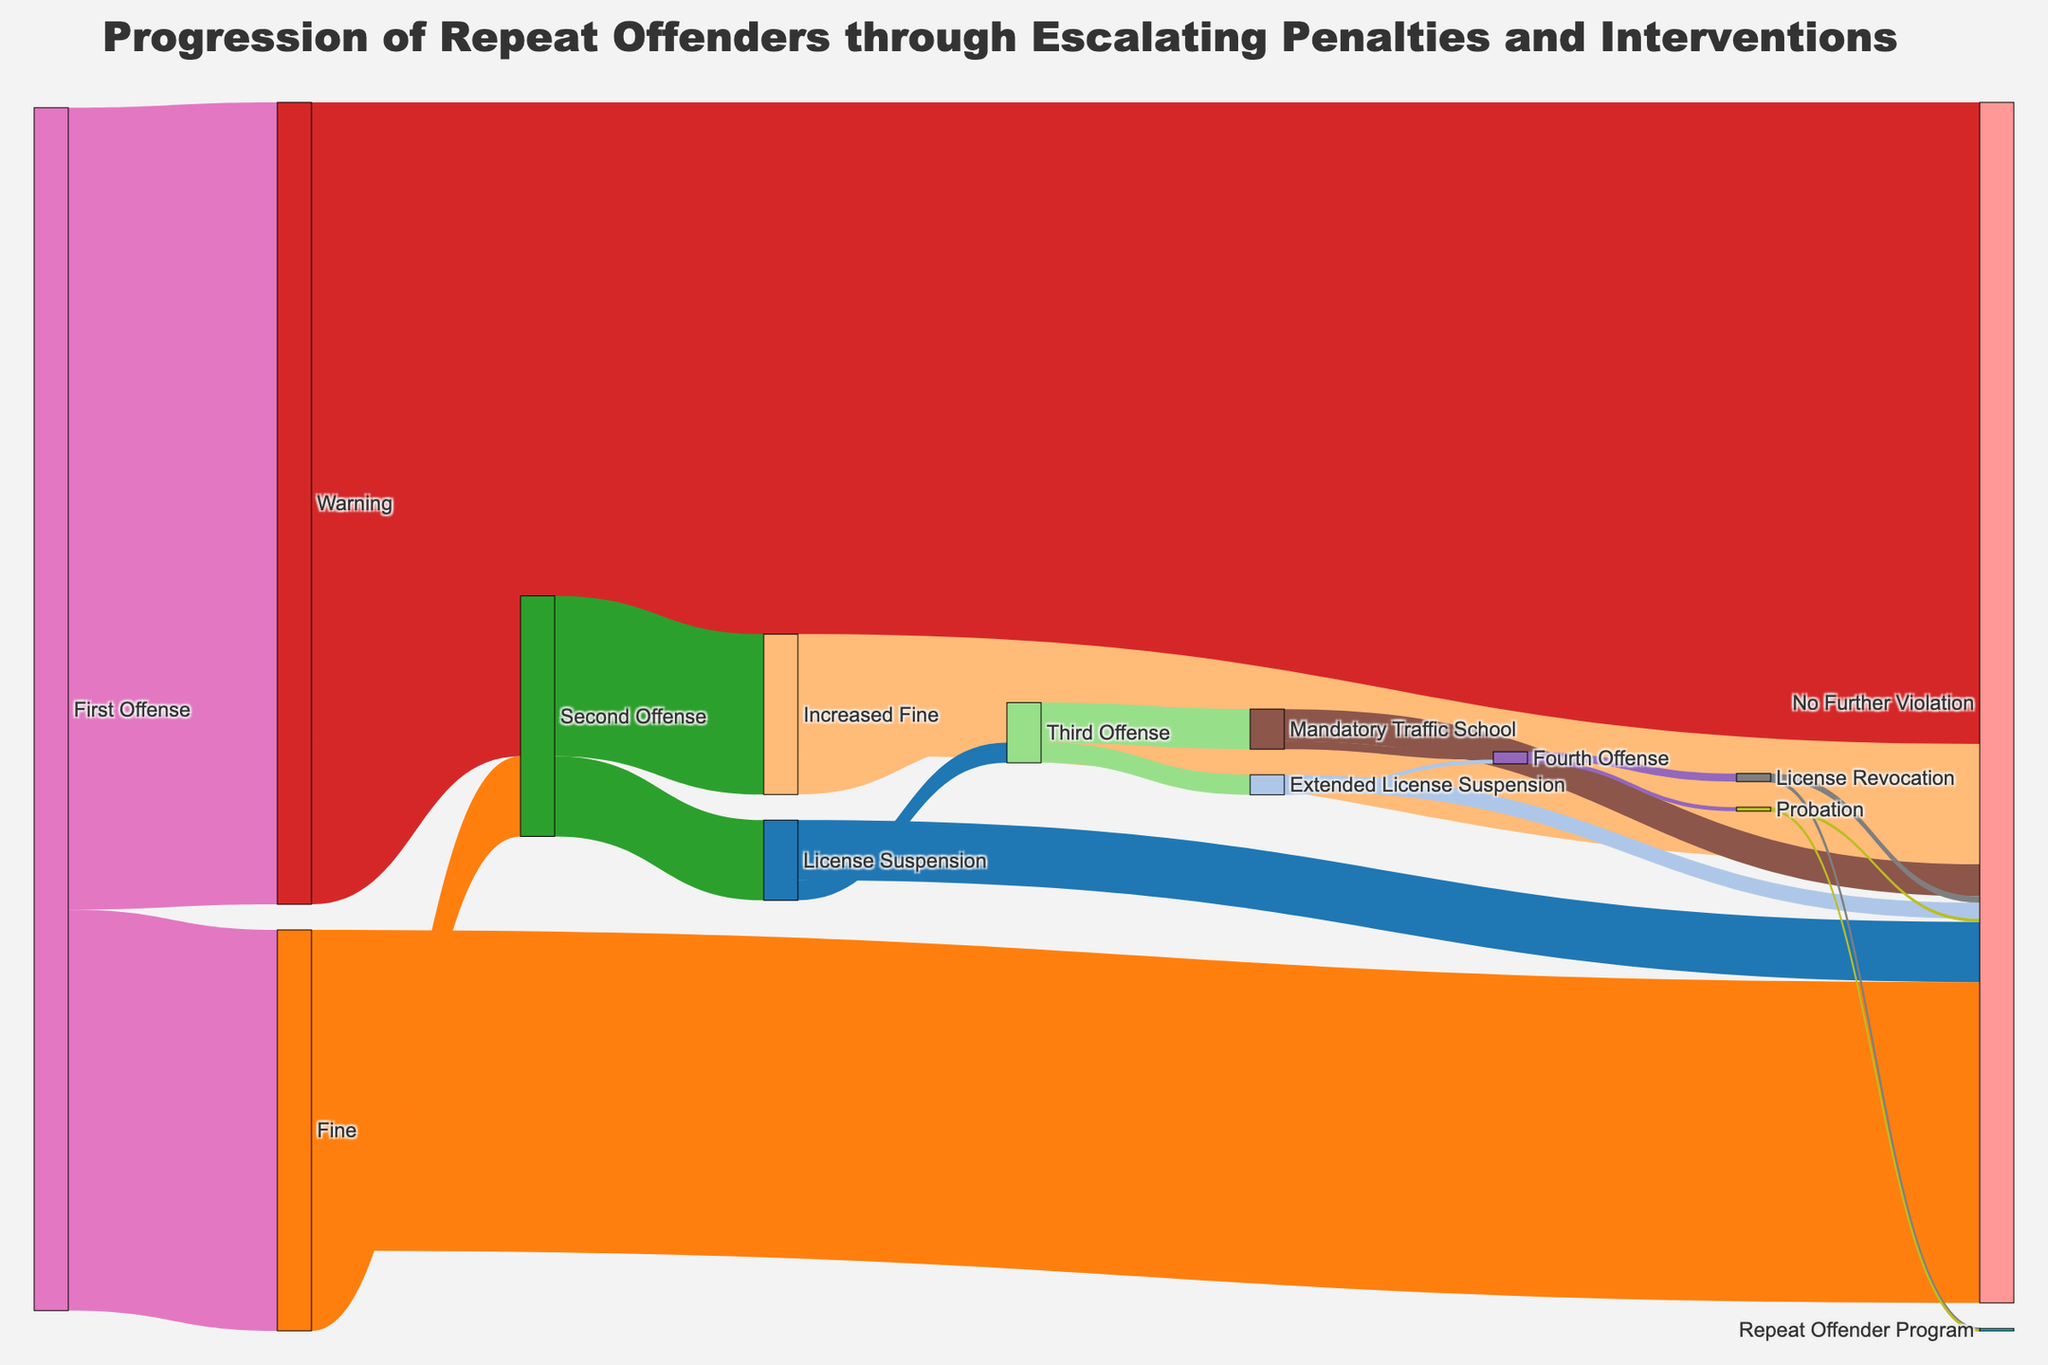What's the title of the Sankey diagram? The title of a Sankey diagram is usually displayed prominently at the top of the figure. Look for a large, bold text that summarizes the main theme of the chart.
Answer: "Progression of Repeat Offenders through Escalating Penalties and Interventions" How many individuals received a warning after their first offense? Find the flow labeled "First Offense" leading to "Warning" and look at the associated value.
Answer: 1000 What percentage of individuals who received a warning did not have further violations? Locate the flow from "Warning" to "No Further Violation" and the flow from "Warning" to "Second Offense." Sum these values to get the total number of individuals who received a warning. Divide the "No Further Violation" value by this total and multiply by 100.
Answer: 80% How many individuals had their licenses suspended after their second offense? Look at the flow labeled "Second Offense" leading to "License Suspension" and find the associated value.
Answer: 100 What is the total number of people who reached the "Third Offense" stage? Sum the values of flows leading to "Third Offense" from "Increased Fine" and "License Suspension."
Answer: 50 + 25 = 75 Which intervention stage has the smallest number of individuals proceeding to the "Repeat Offender Program"? Compare the values of flows leading to "Repeat Offender Program" from both "License Revocation" and "Probation." The stage with the smaller value is the answer.
Answer: Probation (1) What is the final stage that the highest number of individuals reach without further violations? Observe the final stages leading to "No Further Violation" and identify the stage with the highest value. Multiple stages end here: "Warning," "Fine," "Increased Fine," "License Suspension," "Mandatory Traffic School," and "Extended License Suspension." Summing these values will identify the stage contributing the most.
Answer: Warning (800) How many individuals were mandated to attend traffic school after their third offense? Find the flow from "Third Offense" to "Mandatory Traffic School" and identify the value associated with it.
Answer: 50 What percentage of individuals were fine after their first offense relative to the total flow of first offenses? Find the flow from "First Offense" to "Fine" and the total number of first offenses. Divide the value for fines by the total number of first offenses and multiply by 100.
Answer: (500 / (1000 + 500)) * 100 = 33.33% After attending mandatory traffic school, how many individuals committed a fourth offense? Look at the flow from "Mandatory Traffic School" to "Fourth Offense" and identify the value associated with it.
Answer: 10 